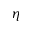<formula> <loc_0><loc_0><loc_500><loc_500>\eta</formula> 